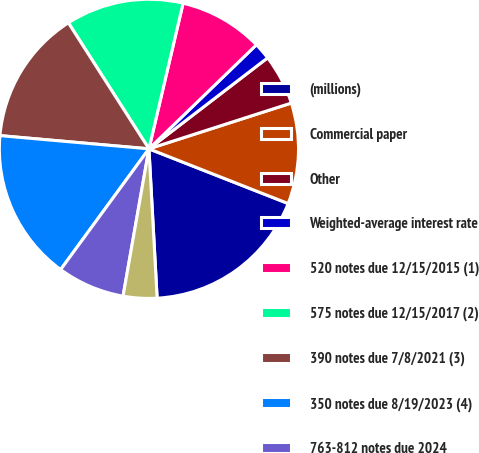<chart> <loc_0><loc_0><loc_500><loc_500><pie_chart><fcel>(millions)<fcel>Commercial paper<fcel>Other<fcel>Weighted-average interest rate<fcel>520 notes due 12/15/2015 (1)<fcel>575 notes due 12/15/2017 (2)<fcel>390 notes due 7/8/2021 (3)<fcel>350 notes due 8/19/2023 (4)<fcel>763-812 notes due 2024<fcel>Unamortized discounts and fair<nl><fcel>18.17%<fcel>10.91%<fcel>5.46%<fcel>1.83%<fcel>9.09%<fcel>12.72%<fcel>14.54%<fcel>16.36%<fcel>7.28%<fcel>3.64%<nl></chart> 